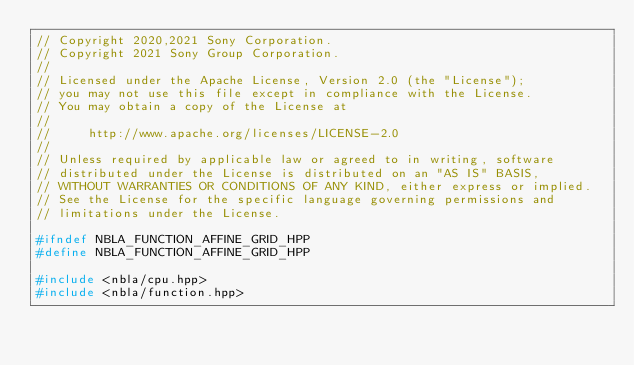<code> <loc_0><loc_0><loc_500><loc_500><_C++_>// Copyright 2020,2021 Sony Corporation.
// Copyright 2021 Sony Group Corporation.
//
// Licensed under the Apache License, Version 2.0 (the "License");
// you may not use this file except in compliance with the License.
// You may obtain a copy of the License at
//
//     http://www.apache.org/licenses/LICENSE-2.0
//
// Unless required by applicable law or agreed to in writing, software
// distributed under the License is distributed on an "AS IS" BASIS,
// WITHOUT WARRANTIES OR CONDITIONS OF ANY KIND, either express or implied.
// See the License for the specific language governing permissions and
// limitations under the License.

#ifndef NBLA_FUNCTION_AFFINE_GRID_HPP
#define NBLA_FUNCTION_AFFINE_GRID_HPP

#include <nbla/cpu.hpp>
#include <nbla/function.hpp></code> 